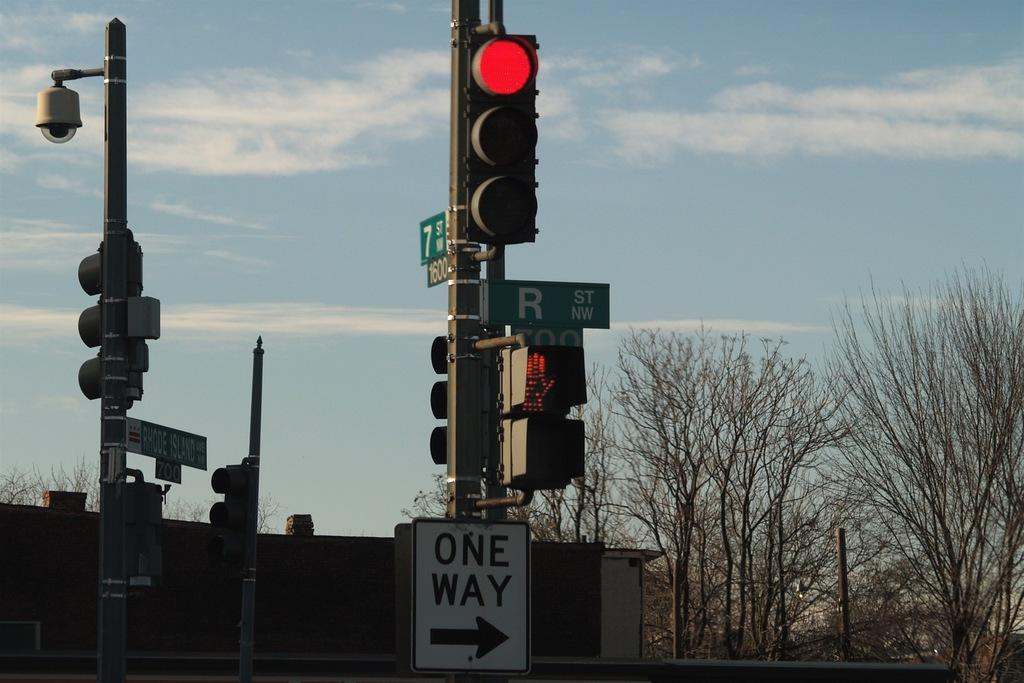<image>
Render a clear and concise summary of the photo. A red stoplight with a One Way sign below it. 